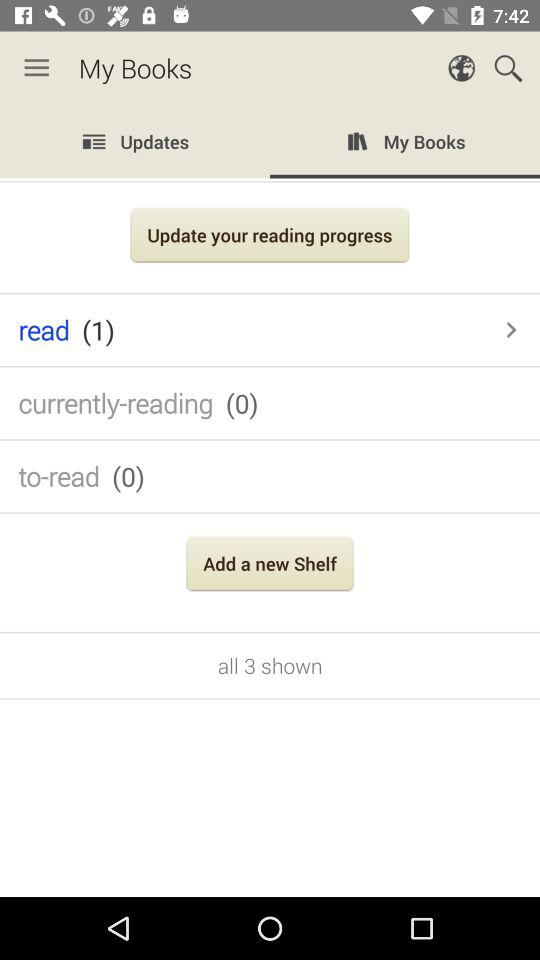Which tab is selected? The selected tab is "My Books". 